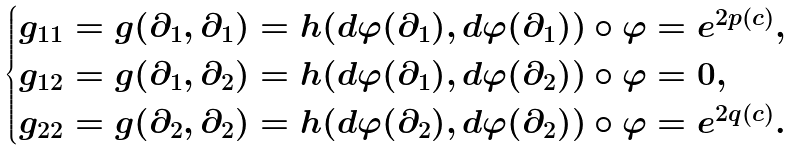Convert formula to latex. <formula><loc_0><loc_0><loc_500><loc_500>\begin{cases} g _ { 1 1 } = g ( \partial _ { 1 } , \partial _ { 1 } ) = h ( d \varphi ( \partial _ { 1 } ) , d \varphi ( \partial _ { 1 } ) ) \circ \varphi = e ^ { 2 p ( c ) } , \\ g _ { 1 2 } = g ( \partial _ { 1 } , \partial _ { 2 } ) = h ( d \varphi ( \partial _ { 1 } ) , d \varphi ( \partial _ { 2 } ) ) \circ \varphi = 0 , \\ g _ { 2 2 } = g ( \partial _ { 2 } , \partial _ { 2 } ) = h ( d \varphi ( \partial _ { 2 } ) , d \varphi ( \partial _ { 2 } ) ) \circ \varphi = e ^ { 2 q ( c ) } . \end{cases}</formula> 